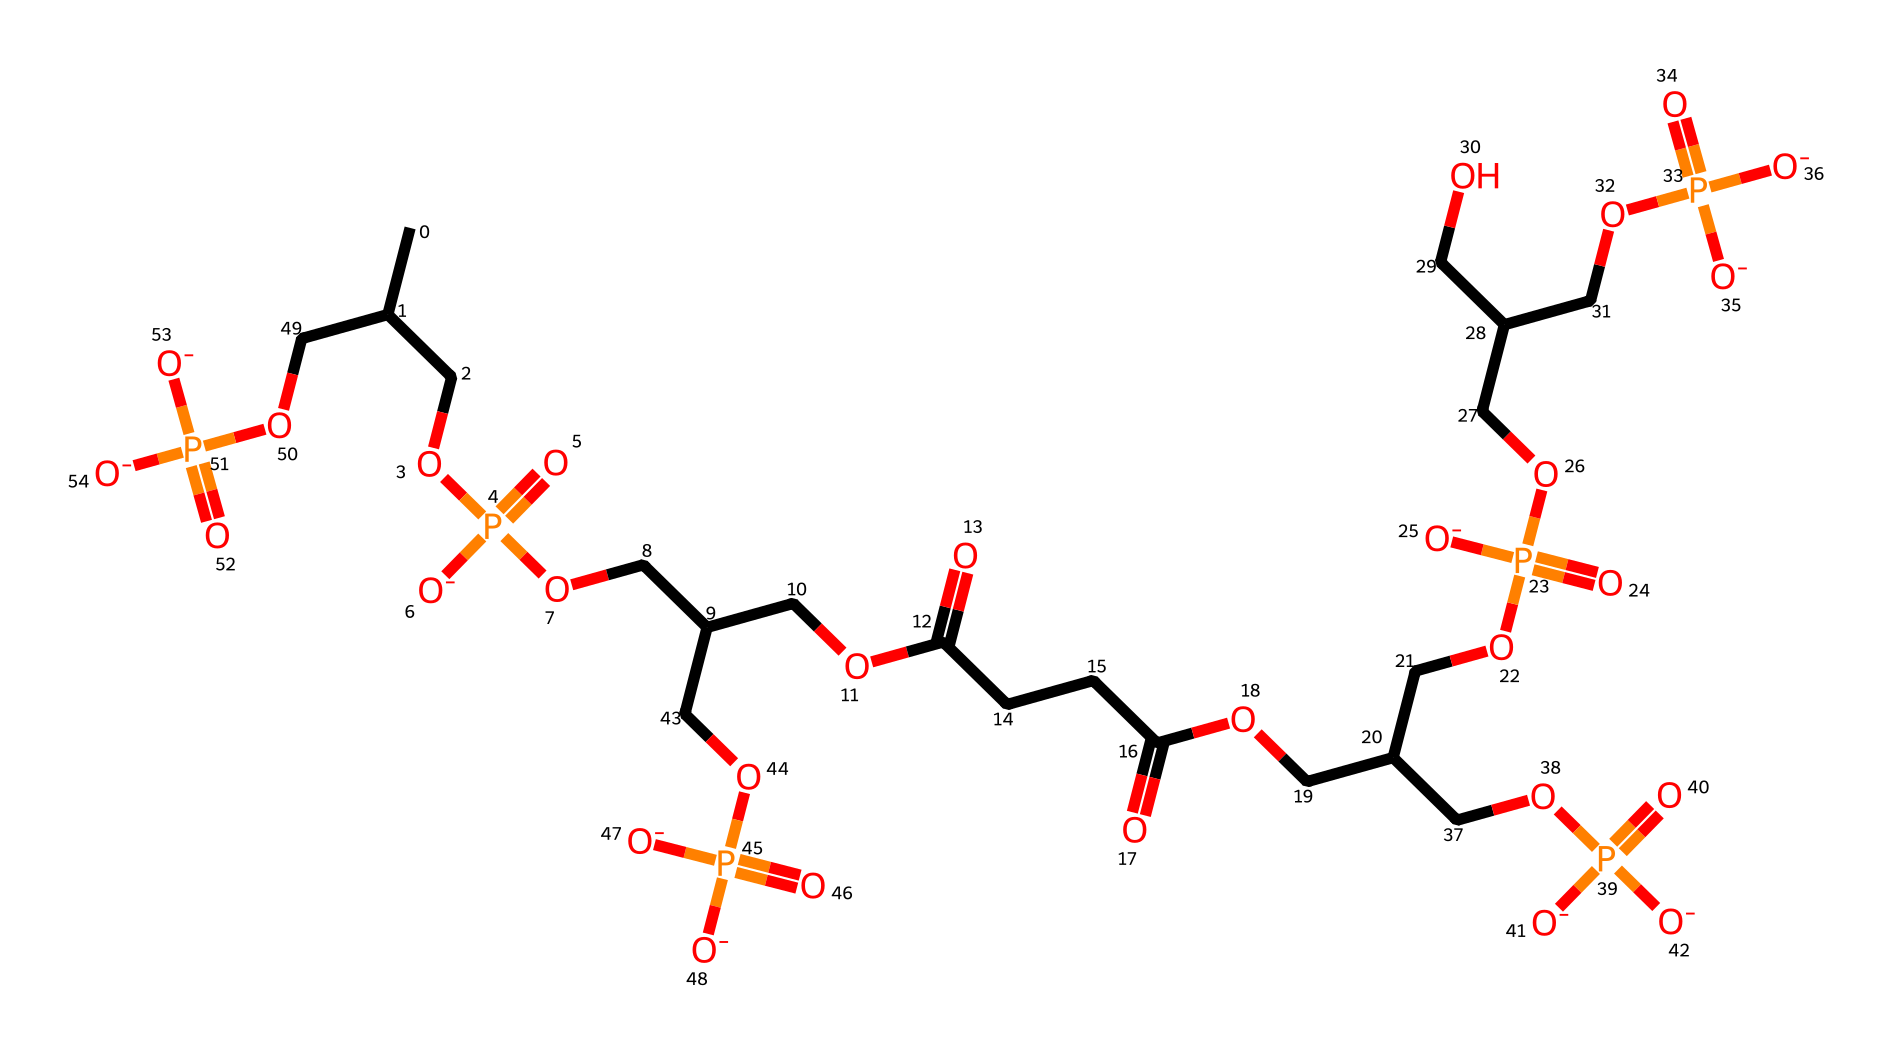What is the total number of carbon atoms in the structure? By examining the SMILES representation, we can count the 'C' characters, which indicate carbon atoms. The chemical has 25 carbon atoms included in various groups.
Answer: 25 How many phosphate groups are present in cardiolipin? In the SMILES representation, the letter 'P' represents phosphate groups. There are four instances of 'P', indicating four phosphate groups in this molecule.
Answer: 4 What type of lipid is cardiolipin classified as? Given that cardiolipin is composed of two fatty acid chains and a glycerol backbone, it is classified as a glycerolipid.
Answer: glycerolipid How many double bonds are present in the fatty acid chains of cardiolipin? While examining the structure, we look for double bonds typically represented by '=' in the SMILES or implied in the structure's description. There are two double bonds in the acryloyl groups of the fatty acids.
Answer: 2 What role does cardiolipin play in mitochondrial membranes? Cardiolipin is crucial for maintaining the integrity and functionality of mitochondrial membranes, contributing to energy production and mitochondrial dynamics.
Answer: integral to energy production Does cardiolipin have any unique structural features relevant to quantum energy transfer? Cardiolipin's unique structure with multiple fatty acid tails and phosphate groups creates a specific molecular arrangement that may facilitate efficient energy transfer, as seen in studies.
Answer: facilitates energy transfer 